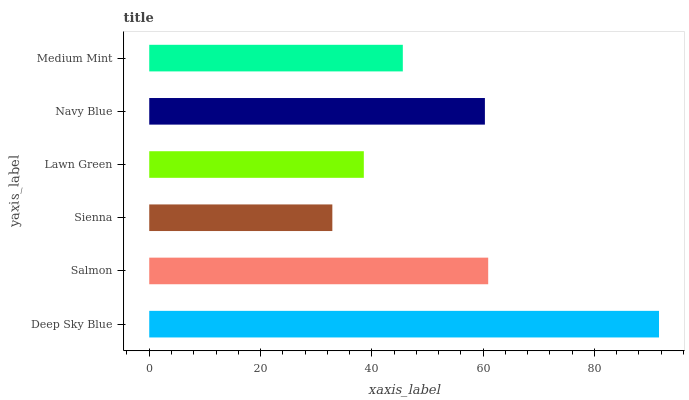Is Sienna the minimum?
Answer yes or no. Yes. Is Deep Sky Blue the maximum?
Answer yes or no. Yes. Is Salmon the minimum?
Answer yes or no. No. Is Salmon the maximum?
Answer yes or no. No. Is Deep Sky Blue greater than Salmon?
Answer yes or no. Yes. Is Salmon less than Deep Sky Blue?
Answer yes or no. Yes. Is Salmon greater than Deep Sky Blue?
Answer yes or no. No. Is Deep Sky Blue less than Salmon?
Answer yes or no. No. Is Navy Blue the high median?
Answer yes or no. Yes. Is Medium Mint the low median?
Answer yes or no. Yes. Is Deep Sky Blue the high median?
Answer yes or no. No. Is Lawn Green the low median?
Answer yes or no. No. 